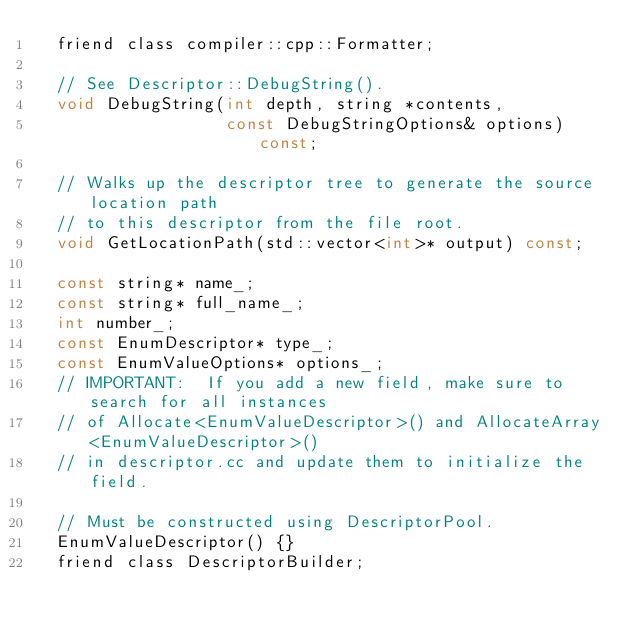<code> <loc_0><loc_0><loc_500><loc_500><_C_>  friend class compiler::cpp::Formatter;

  // See Descriptor::DebugString().
  void DebugString(int depth, string *contents,
                   const DebugStringOptions& options) const;

  // Walks up the descriptor tree to generate the source location path
  // to this descriptor from the file root.
  void GetLocationPath(std::vector<int>* output) const;

  const string* name_;
  const string* full_name_;
  int number_;
  const EnumDescriptor* type_;
  const EnumValueOptions* options_;
  // IMPORTANT:  If you add a new field, make sure to search for all instances
  // of Allocate<EnumValueDescriptor>() and AllocateArray<EnumValueDescriptor>()
  // in descriptor.cc and update them to initialize the field.

  // Must be constructed using DescriptorPool.
  EnumValueDescriptor() {}
  friend class DescriptorBuilder;</code> 